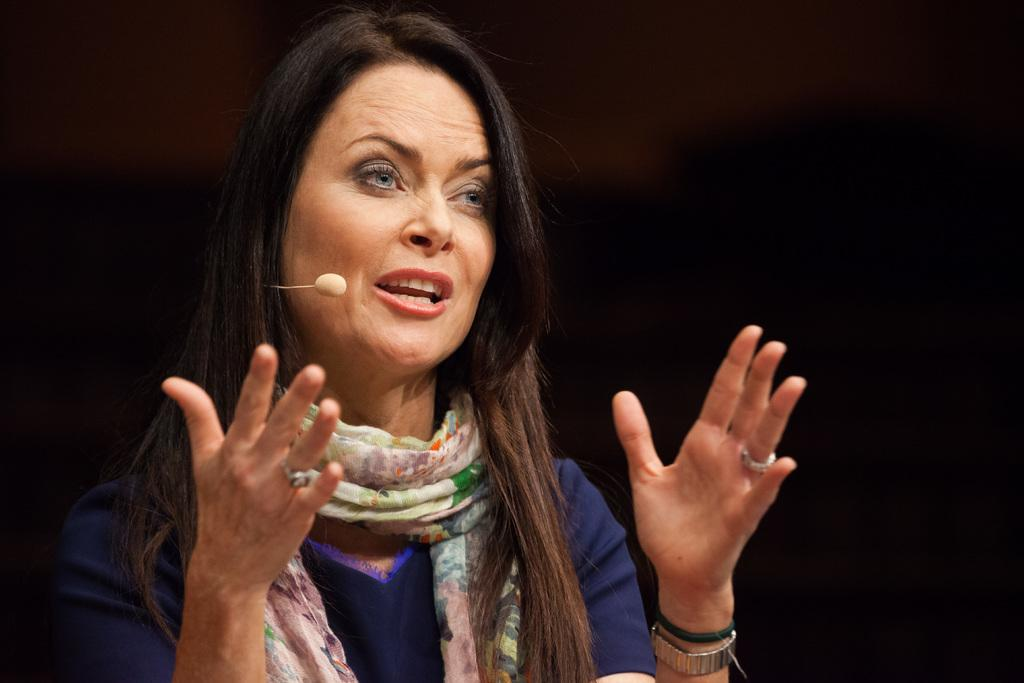Who is present in the image? There is a lady in the image. What is the lady wearing around her neck? The lady is wearing a scarf. What device can be seen in the image? There is a mouth mic in the image. What type of leather can be seen on the swing in the image? There is no swing or leather present in the image. 